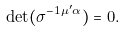Convert formula to latex. <formula><loc_0><loc_0><loc_500><loc_500>\det ( \sigma ^ { - 1 \mu ^ { \prime } \alpha } ) = 0 .</formula> 